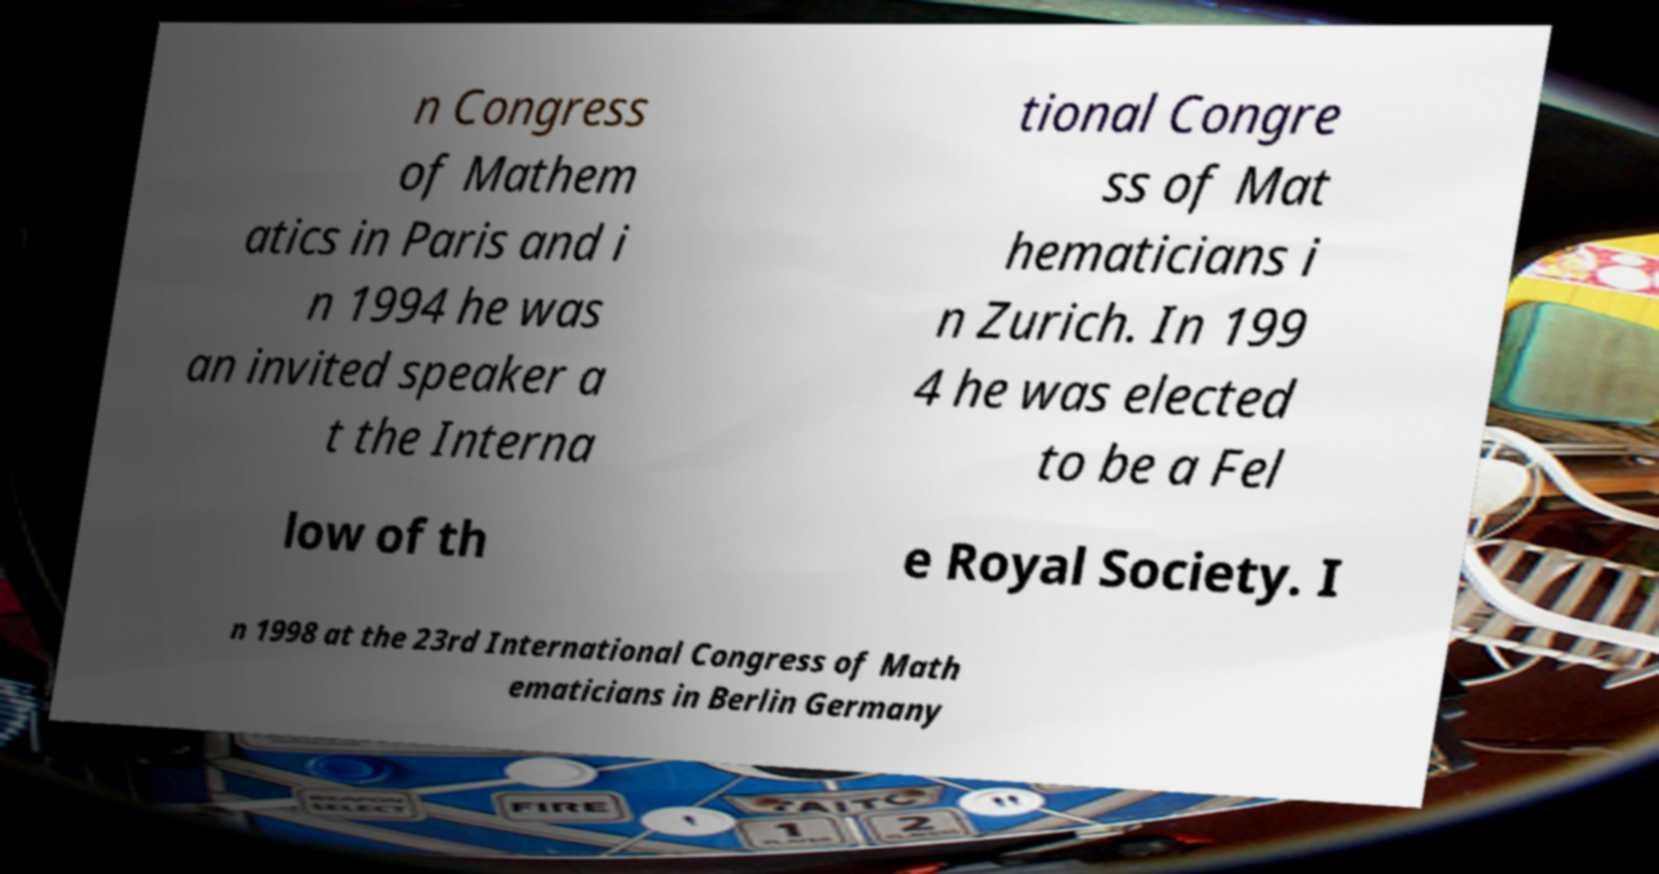There's text embedded in this image that I need extracted. Can you transcribe it verbatim? n Congress of Mathem atics in Paris and i n 1994 he was an invited speaker a t the Interna tional Congre ss of Mat hematicians i n Zurich. In 199 4 he was elected to be a Fel low of th e Royal Society. I n 1998 at the 23rd International Congress of Math ematicians in Berlin Germany 